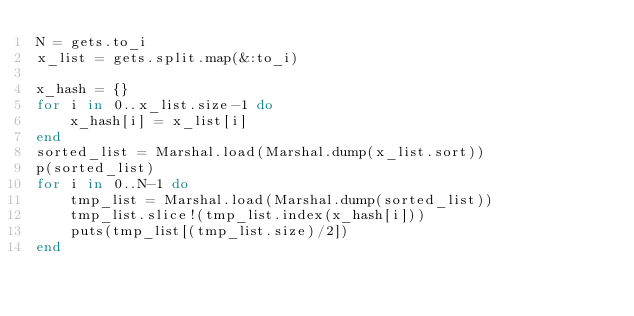Convert code to text. <code><loc_0><loc_0><loc_500><loc_500><_Ruby_>N = gets.to_i
x_list = gets.split.map(&:to_i)

x_hash = {}
for i in 0..x_list.size-1 do
    x_hash[i] = x_list[i]
end
sorted_list = Marshal.load(Marshal.dump(x_list.sort))
p(sorted_list)
for i in 0..N-1 do
    tmp_list = Marshal.load(Marshal.dump(sorted_list))
    tmp_list.slice!(tmp_list.index(x_hash[i]))
    puts(tmp_list[(tmp_list.size)/2])
end</code> 